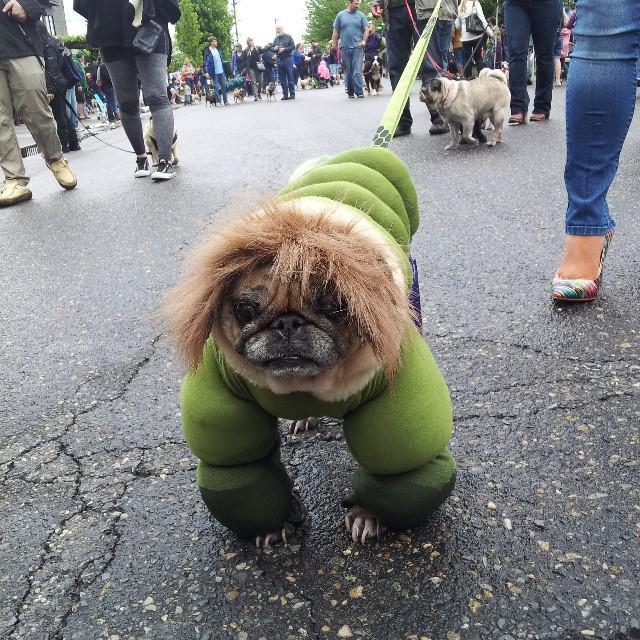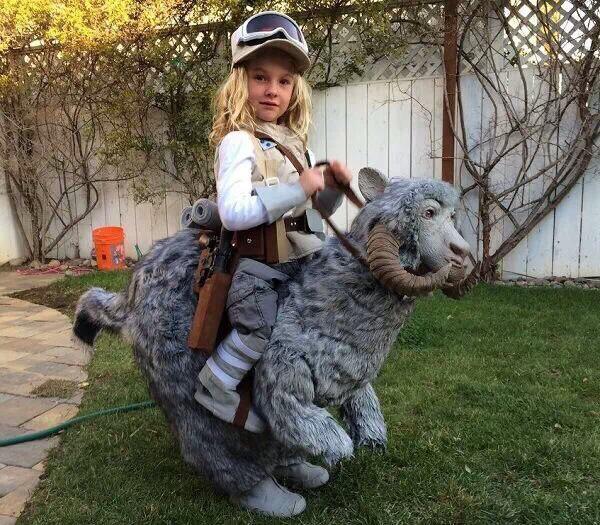The first image is the image on the left, the second image is the image on the right. Evaluate the accuracy of this statement regarding the images: "One image shows a pug with green-dyed fur wearing blue shorts and gazing toward the camera.". Is it true? Answer yes or no. No. The first image is the image on the left, the second image is the image on the right. Evaluate the accuracy of this statement regarding the images: "A dog is showing its tongue in the right image.". Is it true? Answer yes or no. No. 